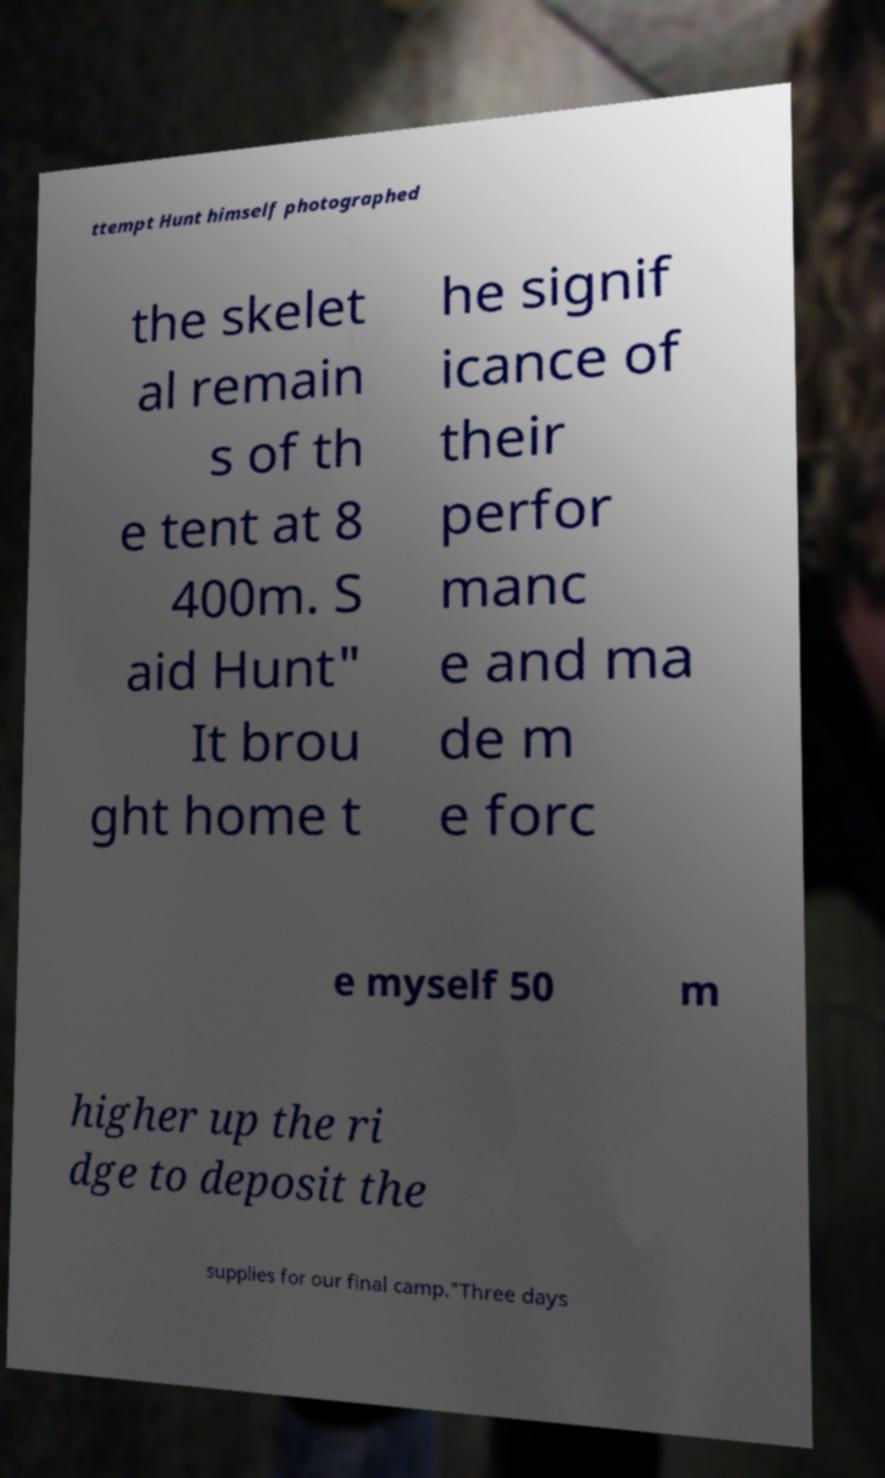What messages or text are displayed in this image? I need them in a readable, typed format. ttempt Hunt himself photographed the skelet al remain s of th e tent at 8 400m. S aid Hunt" It brou ght home t he signif icance of their perfor manc e and ma de m e forc e myself 50 m higher up the ri dge to deposit the supplies for our final camp."Three days 